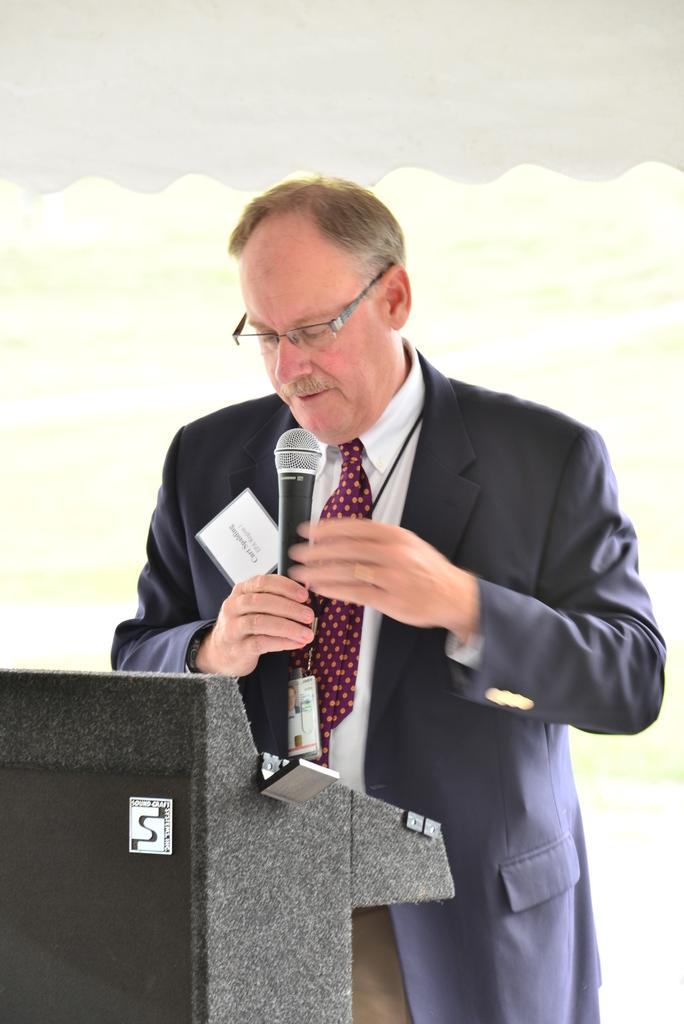Who is the main subject in the image? There is a man in the image. What is the man doing in the image? The man is standing and talking into a microphone. What object is present in the image that the man might be using? There is a podium in the image. What color is the feather that the man is using to paint the ground in the image? There is no feather or painting activity present in the image. 